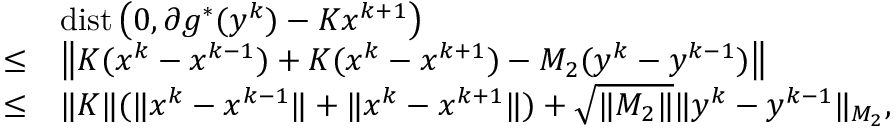Convert formula to latex. <formula><loc_0><loc_0><loc_500><loc_500>\begin{array} { r l & { d i s t \left ( 0 , \partial g ^ { * } ( y ^ { k } ) - K x ^ { k + 1 } \right ) } \\ { \leq } & { \left \| K ( x ^ { k } - x ^ { k - 1 } ) + K ( x ^ { k } - x ^ { k + 1 } ) - M _ { 2 } ( y ^ { k } - y ^ { k - 1 } ) \right \| } \\ { \leq } & { \| K \| ( \| x ^ { k } - x ^ { k - 1 } \| + \| x ^ { k } - x ^ { k + 1 } \| ) + \sqrt { \| M _ { 2 } \| } \| y ^ { k } - y ^ { k - 1 } \| _ { M _ { 2 } } , } \end{array}</formula> 